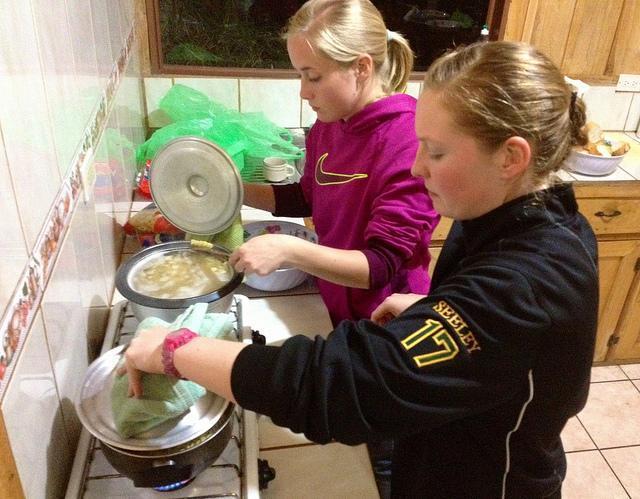How many people are visible?
Give a very brief answer. 2. 